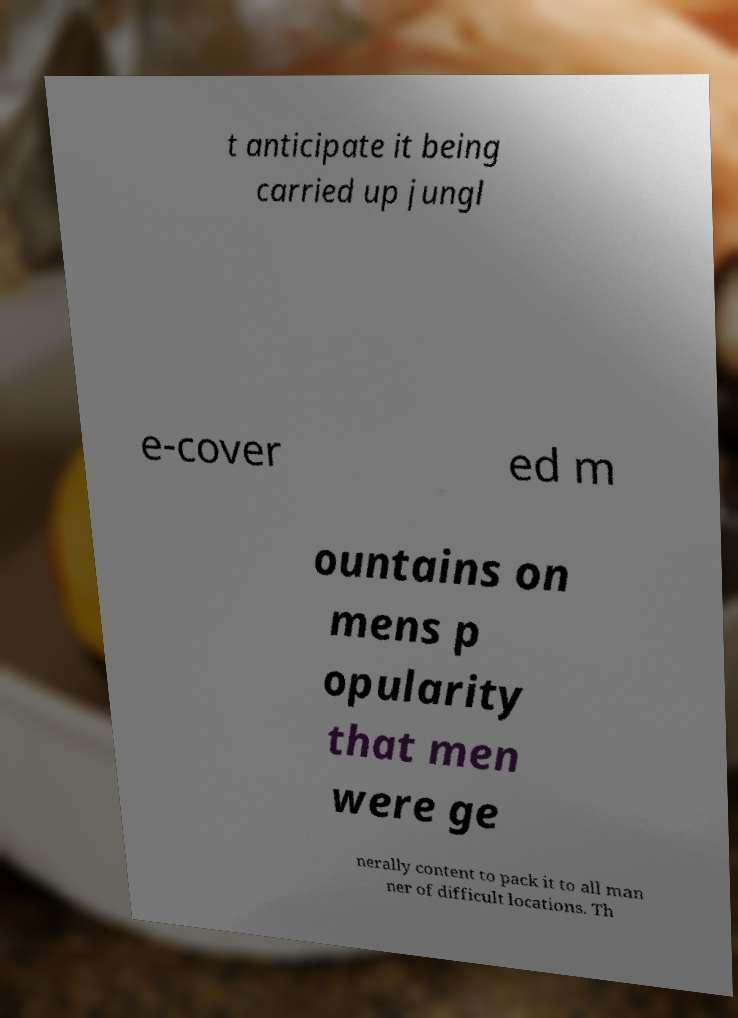What messages or text are displayed in this image? I need them in a readable, typed format. t anticipate it being carried up jungl e-cover ed m ountains on mens p opularity that men were ge nerally content to pack it to all man ner of difficult locations. Th 